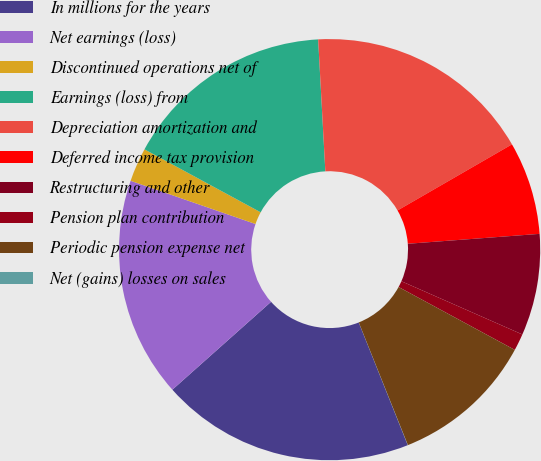Convert chart to OTSL. <chart><loc_0><loc_0><loc_500><loc_500><pie_chart><fcel>In millions for the years<fcel>Net earnings (loss)<fcel>Discontinued operations net of<fcel>Earnings (loss) from<fcel>Depreciation amortization and<fcel>Deferred income tax provision<fcel>Restructuring and other<fcel>Pension plan contribution<fcel>Periodic pension expense net<fcel>Net (gains) losses on sales<nl><fcel>19.47%<fcel>16.88%<fcel>2.6%<fcel>16.23%<fcel>17.53%<fcel>7.14%<fcel>7.79%<fcel>1.3%<fcel>11.04%<fcel>0.01%<nl></chart> 